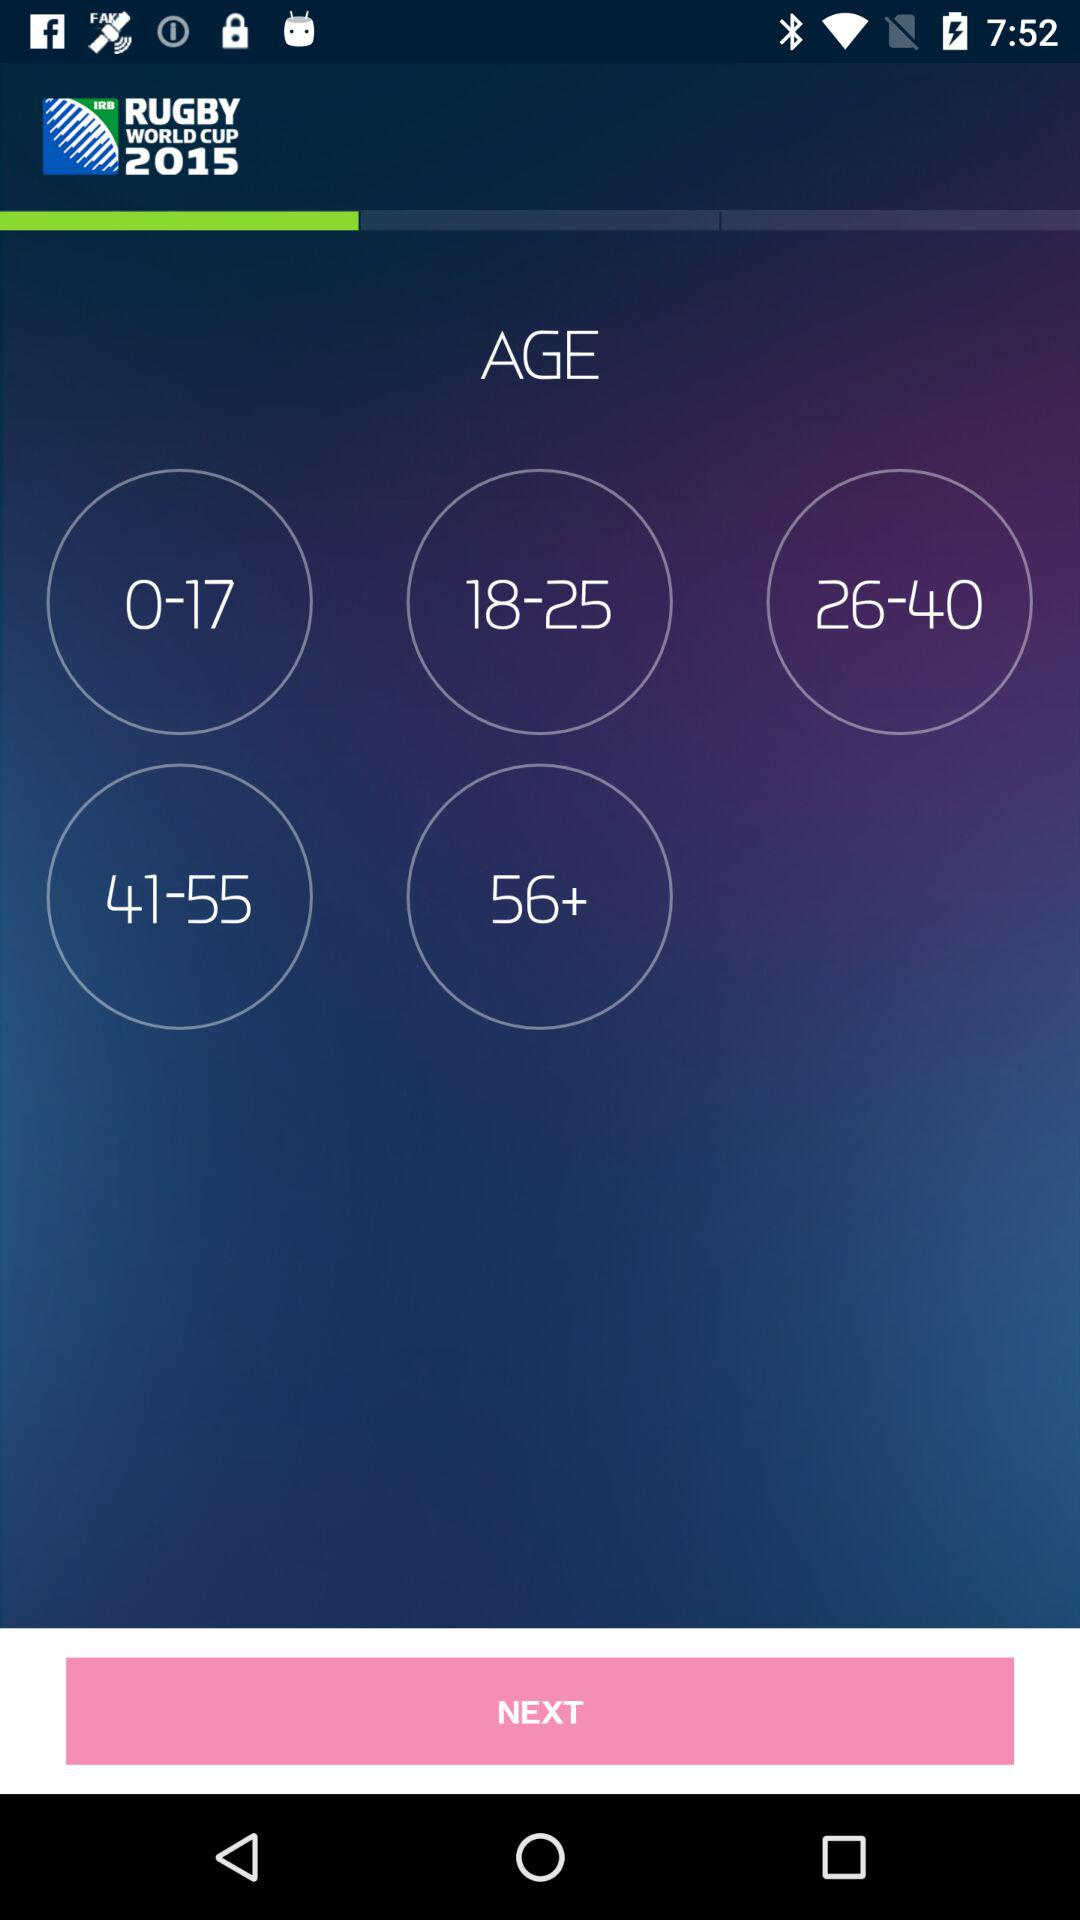What is the application name? The application name is "RUGBY WORLD CUP 2015". 